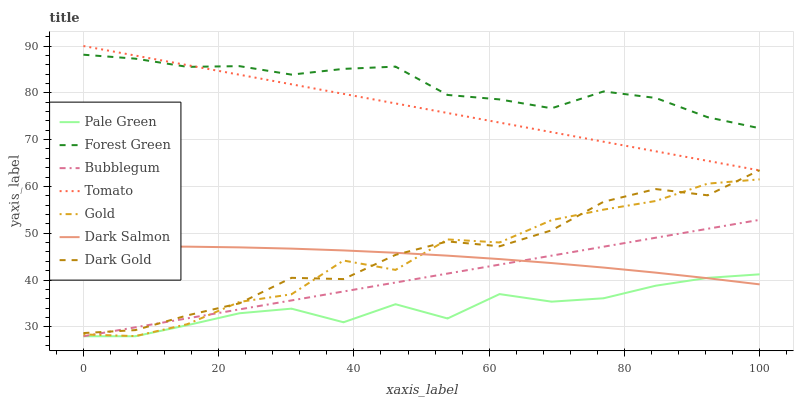Does Pale Green have the minimum area under the curve?
Answer yes or no. Yes. Does Forest Green have the maximum area under the curve?
Answer yes or no. Yes. Does Gold have the minimum area under the curve?
Answer yes or no. No. Does Gold have the maximum area under the curve?
Answer yes or no. No. Is Tomato the smoothest?
Answer yes or no. Yes. Is Gold the roughest?
Answer yes or no. Yes. Is Dark Gold the smoothest?
Answer yes or no. No. Is Dark Gold the roughest?
Answer yes or no. No. Does Bubblegum have the lowest value?
Answer yes or no. Yes. Does Gold have the lowest value?
Answer yes or no. No. Does Tomato have the highest value?
Answer yes or no. Yes. Does Gold have the highest value?
Answer yes or no. No. Is Pale Green less than Tomato?
Answer yes or no. Yes. Is Forest Green greater than Bubblegum?
Answer yes or no. Yes. Does Bubblegum intersect Pale Green?
Answer yes or no. Yes. Is Bubblegum less than Pale Green?
Answer yes or no. No. Is Bubblegum greater than Pale Green?
Answer yes or no. No. Does Pale Green intersect Tomato?
Answer yes or no. No. 